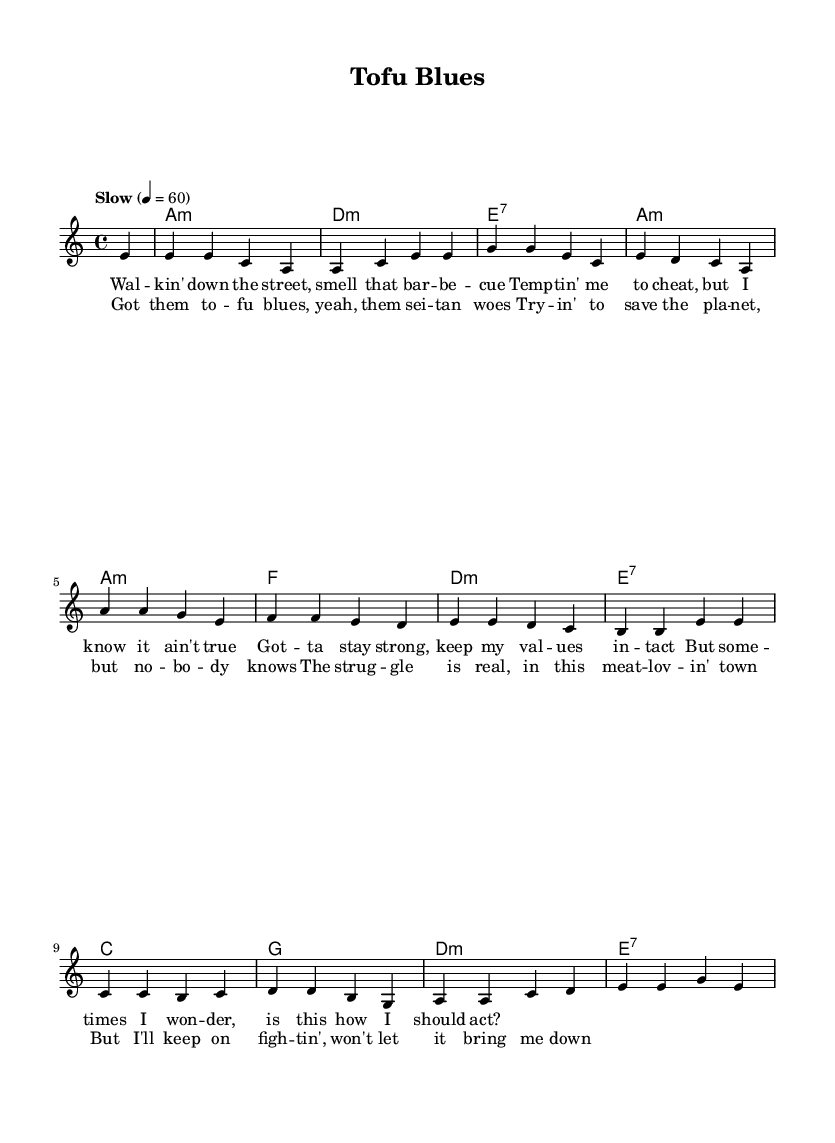What is the key signature of this music? The key signature is A minor, which is indicated by the key signature at the beginning of the piece. A minor has no sharps or flats.
Answer: A minor What is the time signature of this piece? The time signature is 4/4, which is shown at the beginning of the score and indicates that there are four beats in each measure.
Answer: 4/4 What is the tempo marking for this music? The tempo marking is "Slow," which indicates that the piece should be played at a slow pace, specifically 60 beats per minute.
Answer: Slow How many measures are in the verse section? The verse section has four measures, which can be counted by identifying the sections of melody with respective lyrics, and visually scanning the sheet music.
Answer: 4 What are the first two chords in the harmony? The first two chords are A minor and D minor, which can be seen at the beginning of the chord progression in the harmonies section.
Answer: A minor, D minor What type of music is this piece? This piece is a Blues ballad, which is identified by the structure, lyrical theme of lamenting challenges, and specific characteristics of blues music such as emotional storytelling.
Answer: Blues ballad How does the chorus differ from the verse? The chorus differs from the verse in terms of content and emotional intensity; it highlights the main theme of the struggle in the vegan lifestyle, while the verse presents a narrative.
Answer: Theme and intensity 